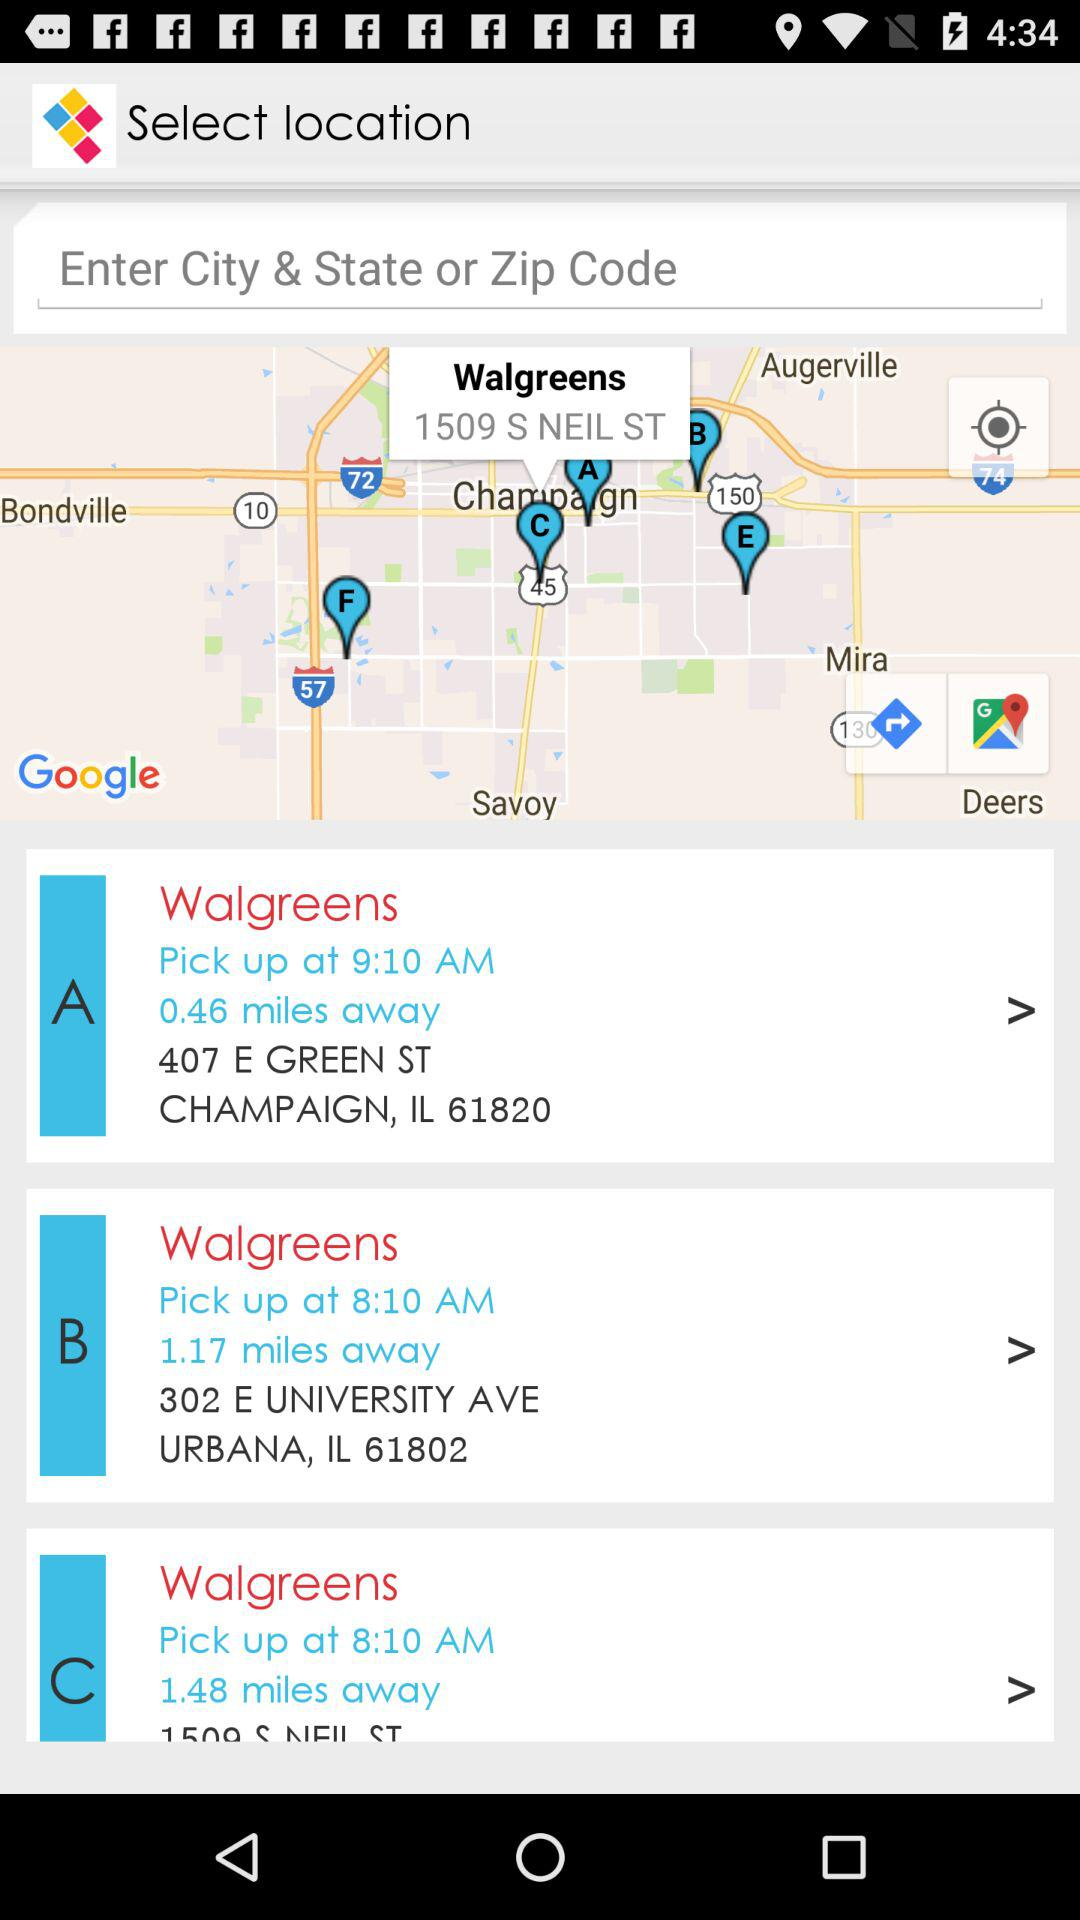What is the shown city? The shown cities are Champaign and Urbana. 